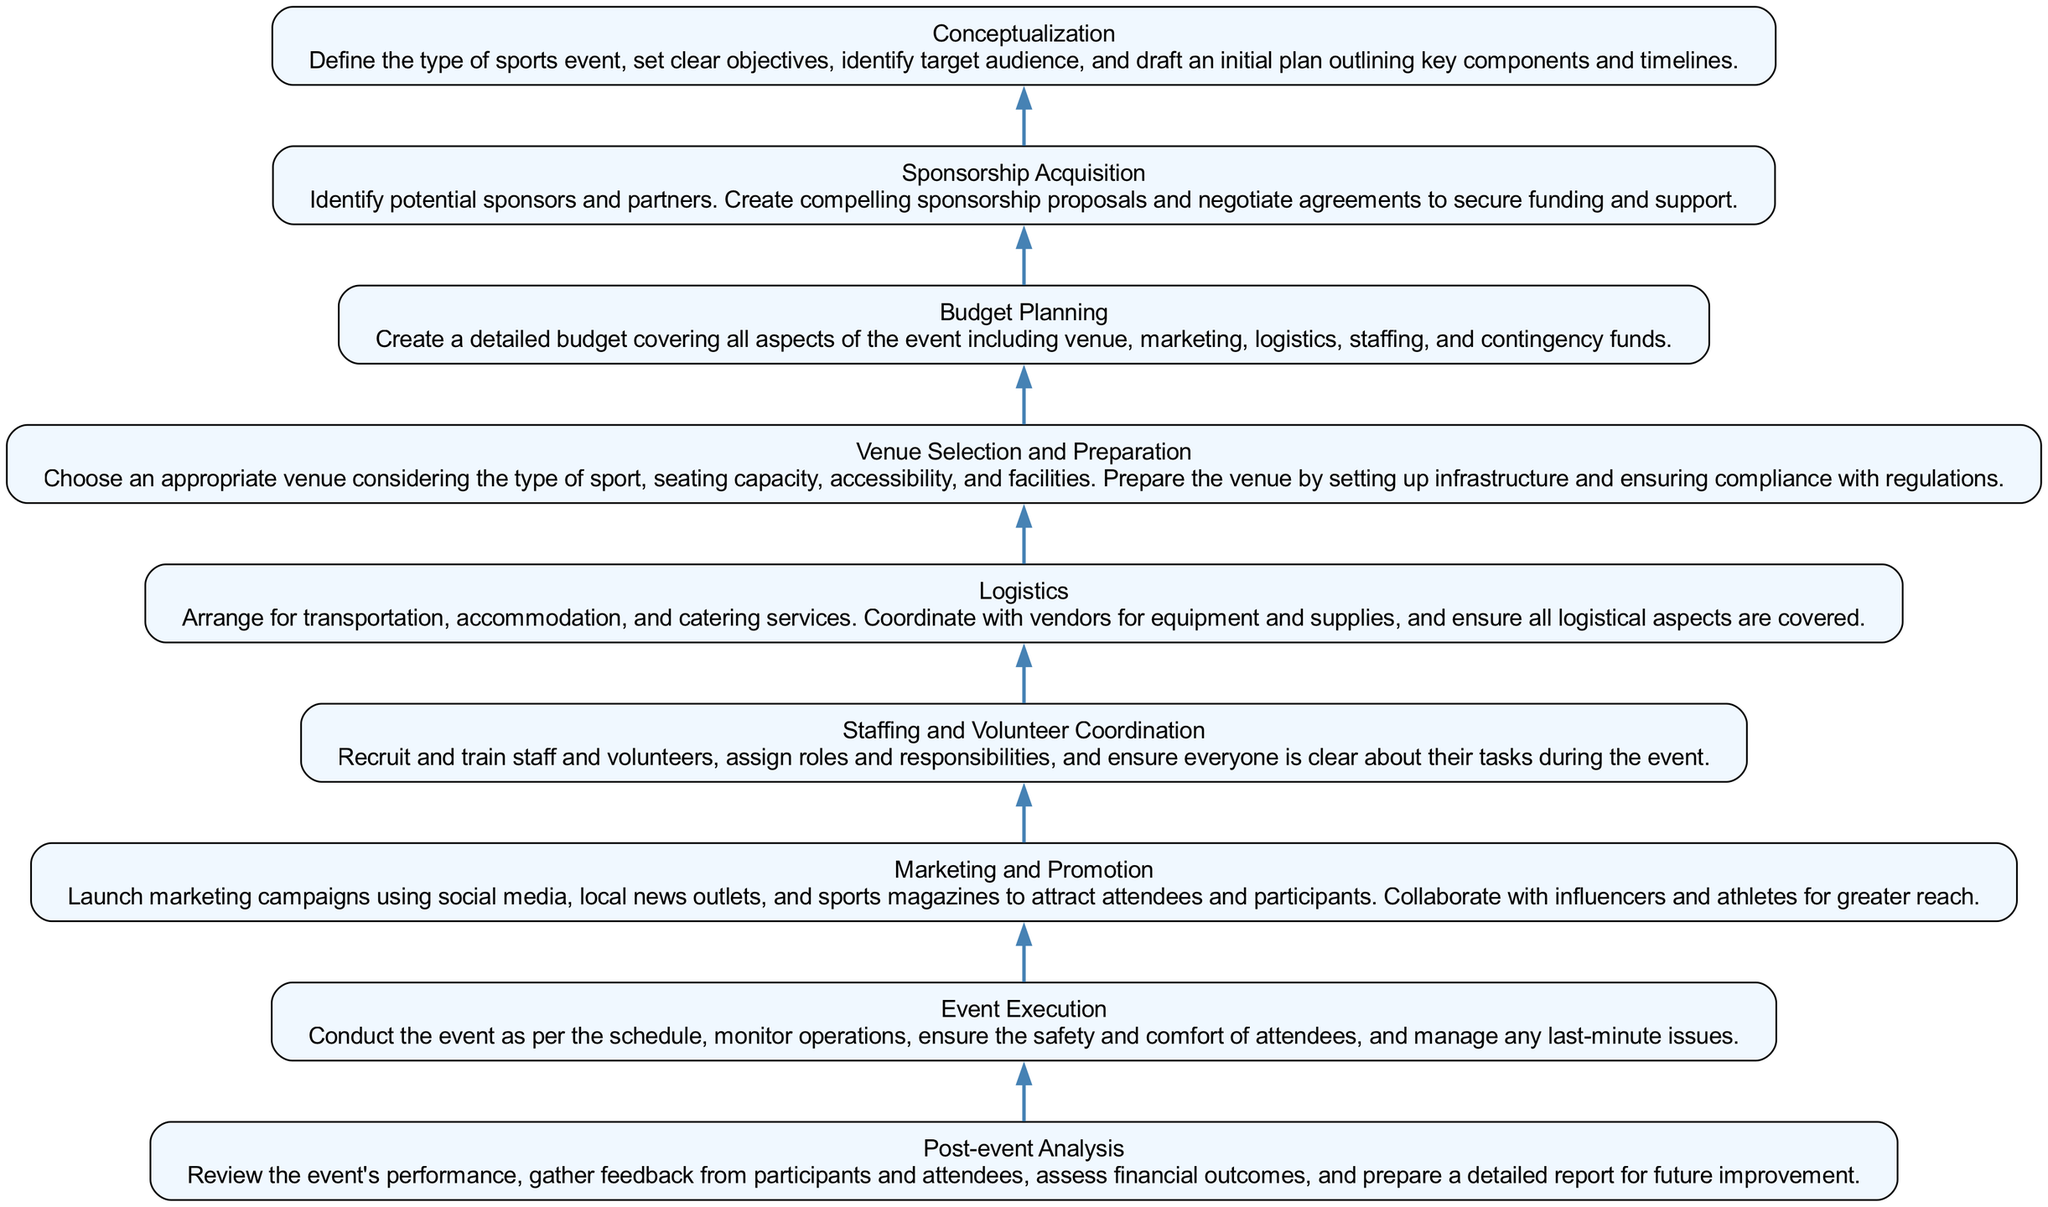What is the top node of the diagram? The top node in a bottom-to-up flow chart is typically the final step of the process, which is "Post-event Analysis", as it signifies the conclusion of the event organization process.
Answer: Post-event Analysis How many nodes are in the diagram? The diagram contains 9 different nodes, each representing a unique step in the organization of a sports event.
Answer: 9 What is the immediate predecessor of "Event Execution"? According to the flow of the chart, "Event Execution" follows "Logistics", which indicates that logistics need to be arranged before the event is conducted.
Answer: Logistics Identify the relationship between "Marketing and Promotion" and "Sponsorship Acquisition". In the flow chart, "Marketing and Promotion" and "Sponsorship Acquisition" are separate nodes but both feed into the "Budget Planning" stage, which means they contribute to financial planning for the event.
Answer: Contributing to Budget Planning What process comes directly after "Budget Planning"? Based on the flow chart, the step that directly follows "Budget Planning" is "Sponsorship Acquisition", indicating that securing sponsorship is dependent on having a structured budget.
Answer: Sponsorship Acquisition Which two nodes are involved in the execution of the event? The nodes "Logistics" and "Event Execution" are the primary stages involved in the actual implementation of the sports event as they deal with arrangements and conducting the event itself.
Answer: Logistics, Event Execution What step follows "Conceptualization" in the event organization process? "Conceptualization" is the first step and is immediately followed by "Budget Planning", which suggests that planning follows the initial concept of the event.
Answer: Budget Planning Which node is the first in the diagram? The first step in the process is "Conceptualization", which lays the groundwork for the sports event before any further actions are taken.
Answer: Conceptualization What is the last node in the flow chart? The final node in the flow chart is "Post-event Analysis", representing the review and assessment stage that occurs after the event is completed.
Answer: Post-event Analysis 